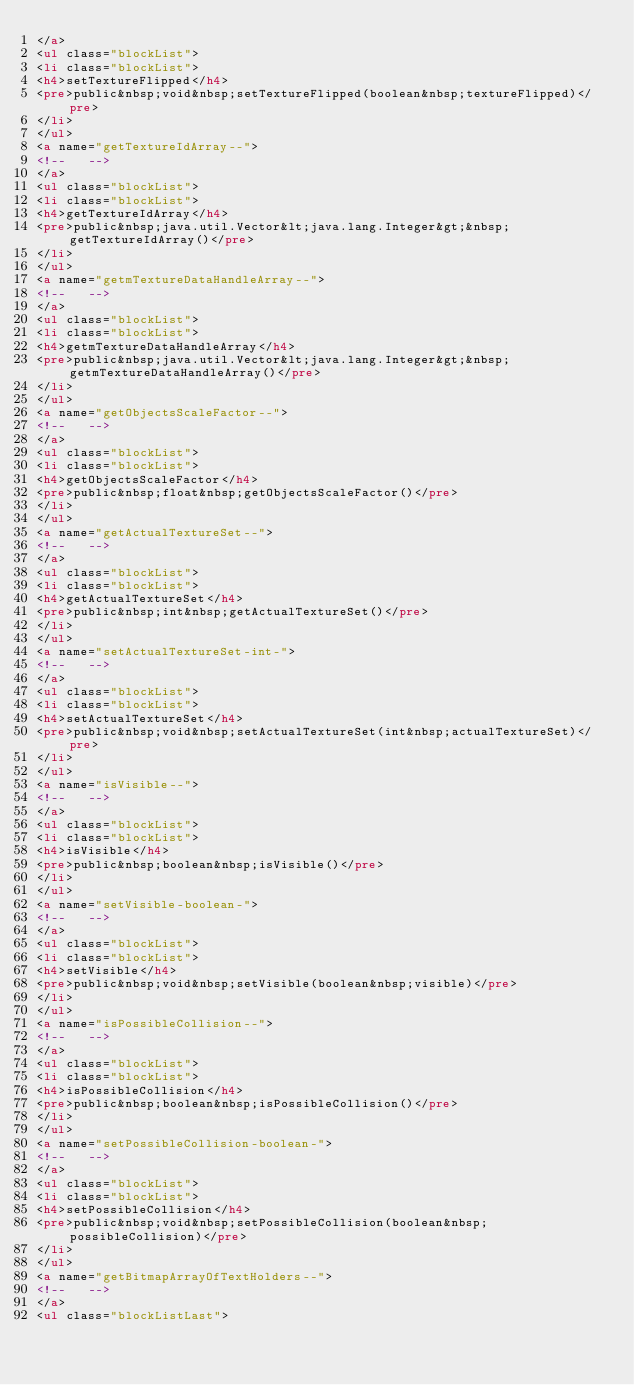<code> <loc_0><loc_0><loc_500><loc_500><_HTML_></a>
<ul class="blockList">
<li class="blockList">
<h4>setTextureFlipped</h4>
<pre>public&nbsp;void&nbsp;setTextureFlipped(boolean&nbsp;textureFlipped)</pre>
</li>
</ul>
<a name="getTextureIdArray--">
<!--   -->
</a>
<ul class="blockList">
<li class="blockList">
<h4>getTextureIdArray</h4>
<pre>public&nbsp;java.util.Vector&lt;java.lang.Integer&gt;&nbsp;getTextureIdArray()</pre>
</li>
</ul>
<a name="getmTextureDataHandleArray--">
<!--   -->
</a>
<ul class="blockList">
<li class="blockList">
<h4>getmTextureDataHandleArray</h4>
<pre>public&nbsp;java.util.Vector&lt;java.lang.Integer&gt;&nbsp;getmTextureDataHandleArray()</pre>
</li>
</ul>
<a name="getObjectsScaleFactor--">
<!--   -->
</a>
<ul class="blockList">
<li class="blockList">
<h4>getObjectsScaleFactor</h4>
<pre>public&nbsp;float&nbsp;getObjectsScaleFactor()</pre>
</li>
</ul>
<a name="getActualTextureSet--">
<!--   -->
</a>
<ul class="blockList">
<li class="blockList">
<h4>getActualTextureSet</h4>
<pre>public&nbsp;int&nbsp;getActualTextureSet()</pre>
</li>
</ul>
<a name="setActualTextureSet-int-">
<!--   -->
</a>
<ul class="blockList">
<li class="blockList">
<h4>setActualTextureSet</h4>
<pre>public&nbsp;void&nbsp;setActualTextureSet(int&nbsp;actualTextureSet)</pre>
</li>
</ul>
<a name="isVisible--">
<!--   -->
</a>
<ul class="blockList">
<li class="blockList">
<h4>isVisible</h4>
<pre>public&nbsp;boolean&nbsp;isVisible()</pre>
</li>
</ul>
<a name="setVisible-boolean-">
<!--   -->
</a>
<ul class="blockList">
<li class="blockList">
<h4>setVisible</h4>
<pre>public&nbsp;void&nbsp;setVisible(boolean&nbsp;visible)</pre>
</li>
</ul>
<a name="isPossibleCollision--">
<!--   -->
</a>
<ul class="blockList">
<li class="blockList">
<h4>isPossibleCollision</h4>
<pre>public&nbsp;boolean&nbsp;isPossibleCollision()</pre>
</li>
</ul>
<a name="setPossibleCollision-boolean-">
<!--   -->
</a>
<ul class="blockList">
<li class="blockList">
<h4>setPossibleCollision</h4>
<pre>public&nbsp;void&nbsp;setPossibleCollision(boolean&nbsp;possibleCollision)</pre>
</li>
</ul>
<a name="getBitmapArrayOfTextHolders--">
<!--   -->
</a>
<ul class="blockListLast"></code> 